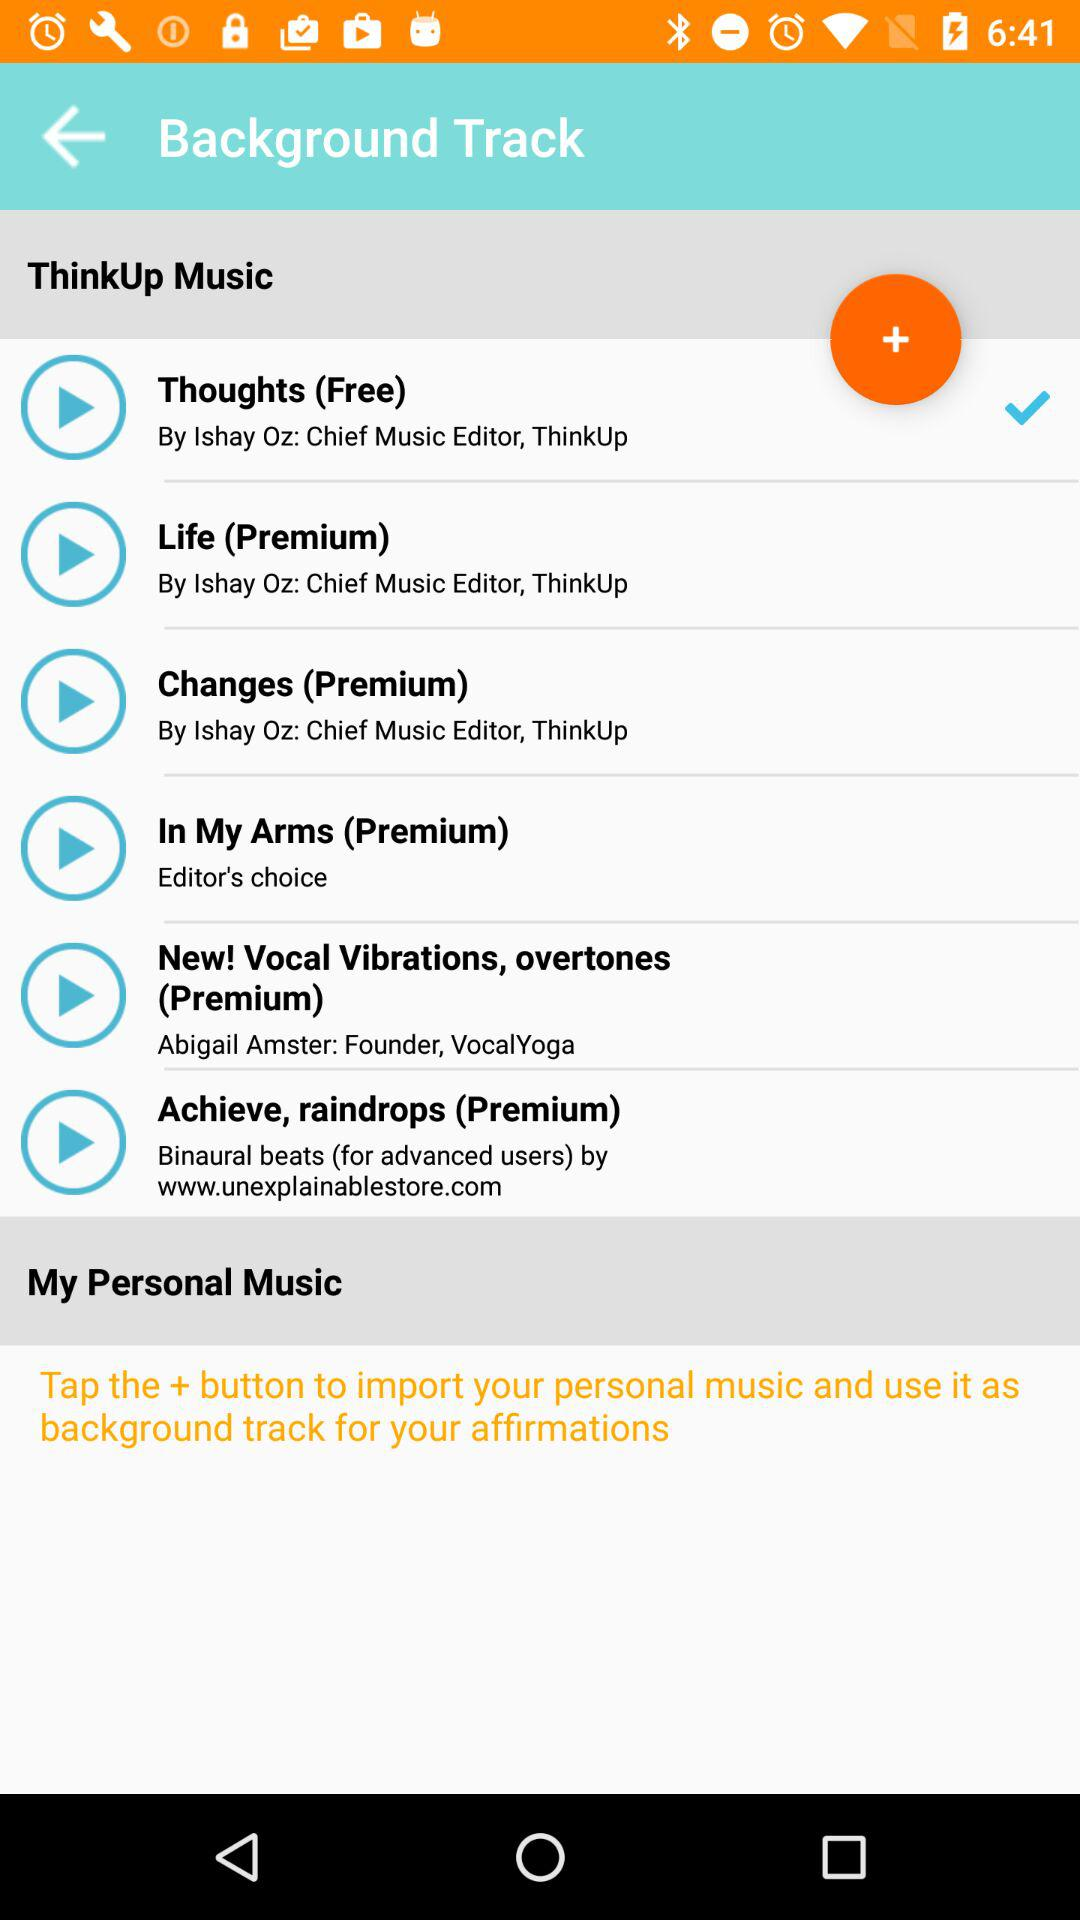What is the name of the singer of the song "Life"? The name of the singer is Lshay. 